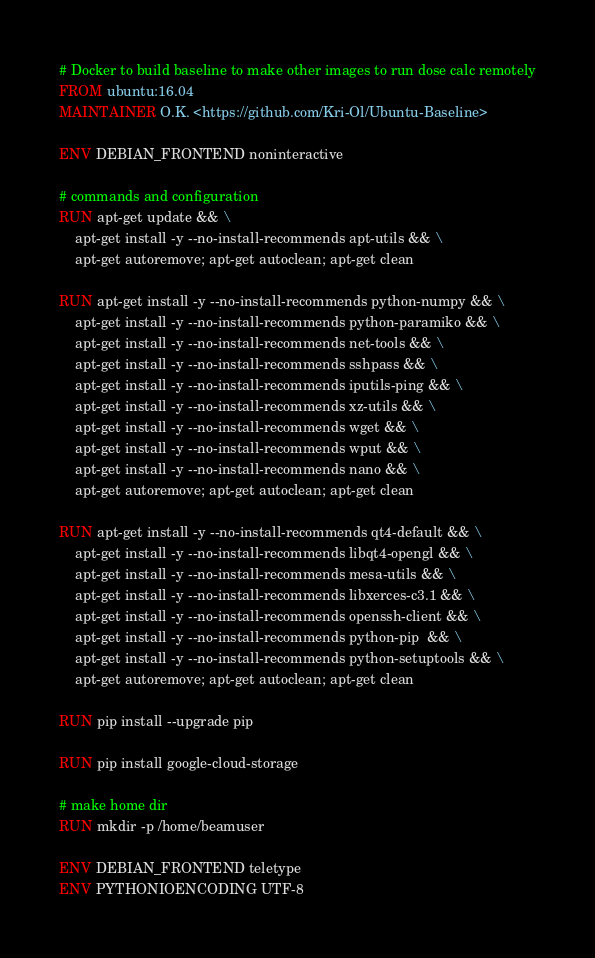Convert code to text. <code><loc_0><loc_0><loc_500><loc_500><_Dockerfile_># Docker to build baseline to make other images to run dose calc remotely
FROM ubuntu:16.04
MAINTAINER O.K. <https://github.com/Kri-Ol/Ubuntu-Baseline>

ENV DEBIAN_FRONTEND noninteractive

# commands and configuration
RUN apt-get update && \
    apt-get install -y --no-install-recommends apt-utils && \
    apt-get autoremove; apt-get autoclean; apt-get clean

RUN apt-get install -y --no-install-recommends python-numpy && \
    apt-get install -y --no-install-recommends python-paramiko && \
    apt-get install -y --no-install-recommends net-tools && \
    apt-get install -y --no-install-recommends sshpass && \
    apt-get install -y --no-install-recommends iputils-ping && \
    apt-get install -y --no-install-recommends xz-utils && \
    apt-get install -y --no-install-recommends wget && \
    apt-get install -y --no-install-recommends wput && \
    apt-get install -y --no-install-recommends nano && \
    apt-get autoremove; apt-get autoclean; apt-get clean

RUN apt-get install -y --no-install-recommends qt4-default && \
    apt-get install -y --no-install-recommends libqt4-opengl && \
    apt-get install -y --no-install-recommends mesa-utils && \
    apt-get install -y --no-install-recommends libxerces-c3.1 && \
    apt-get install -y --no-install-recommends openssh-client && \
    apt-get install -y --no-install-recommends python-pip  && \
    apt-get install -y --no-install-recommends python-setuptools && \
    apt-get autoremove; apt-get autoclean; apt-get clean

RUN pip install --upgrade pip

RUN pip install google-cloud-storage

# make home dir
RUN mkdir -p /home/beamuser

ENV DEBIAN_FRONTEND teletype
ENV PYTHONIOENCODING UTF-8
</code> 